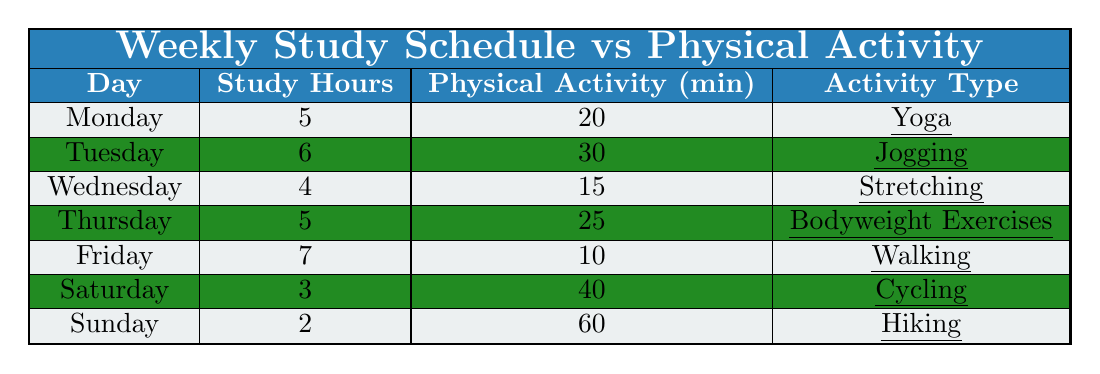What is the total number of study hours for the week? To find the total study hours, sum the study hours for each day: 5 + 6 + 4 + 5 + 7 + 3 + 2 = 32.
Answer: 32 On which day is the most physical activity done? The day with the most physical activity minutes is Sunday with 60 minutes of hiking.
Answer: Sunday Which activity has the least time allocated for physical activity? Monday has the least physical activity time with 20 minutes of yoga.
Answer: Yoga What is the average physical activity time per day? Total physical activity time is 20 + 30 + 15 + 25 + 10 + 40 + 60 = 210 minutes. There are 7 days, so the average is 210 / 7 = 30.
Answer: 30 Was there any day with more than 30 minutes of physical activity? Yes, Tuesday (30) and Sunday (60) both had more than 30 minutes of physical activity.
Answer: Yes Which day had the highest study hours and what was the physical activity type? Friday had the highest study hours at 7 hours, with physical activity type being walking.
Answer: Walking If a student studies for an average of 5 hours a day, how many more study hours were logged on Friday? Friday had 7 study hours, which is 2 hours more than the average (5), calculated as 7 - 5 = 2.
Answer: 2 How many minutes of physical activity were performed on Saturday compared to Wednesday? Saturday had 40 minutes and Wednesday had 15 minutes of physical activity. The difference is 40 - 15 = 25 minutes.
Answer: 25 What percentage of the total weekly study hours is spent on physical activity? Total study hours = 32 and total physical activity minutes = 210. The percentage is (210/32) * 100 ≈ 656.25.
Answer: 656.25% Which day has the highest ratio of study hours to physical activity minutes? Calculate the ratio for each day: Monday (5/20), Tuesday (6/30), Wednesday (4/15), Thursday (5/25), Friday (7/10), Saturday (3/40), Sunday (2/60). The highest ratio is Friday at 7/10 = 0.7.
Answer: Friday 